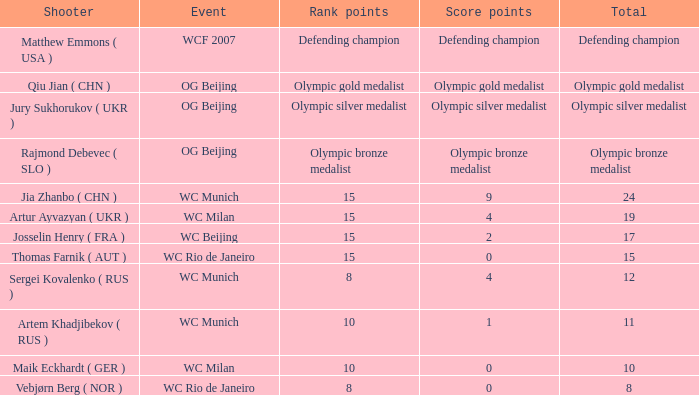With a total of 11, and 10 rank points, what are the score points? 1.0. 